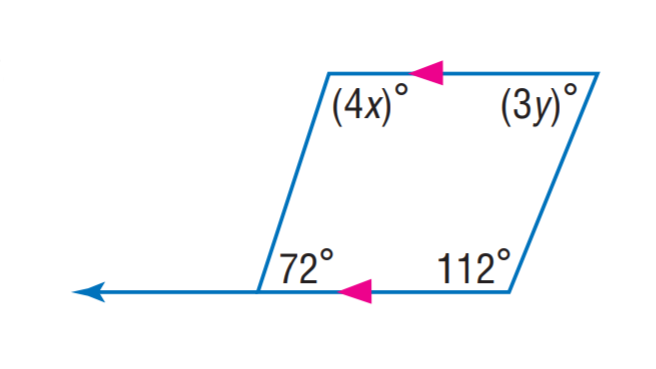Answer the mathemtical geometry problem and directly provide the correct option letter.
Question: Find x.
Choices: A: 24 B: 27 C: 72 D: 112 B 